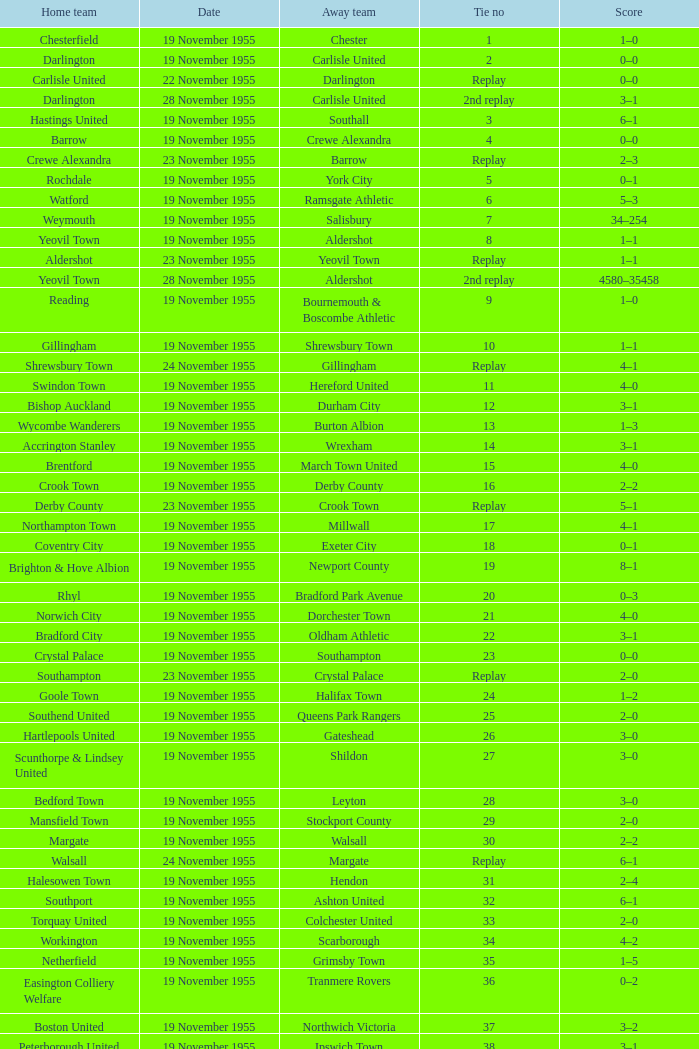What is the home team with scarborough as the away team? Workington. 